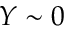Convert formula to latex. <formula><loc_0><loc_0><loc_500><loc_500>Y \sim 0</formula> 